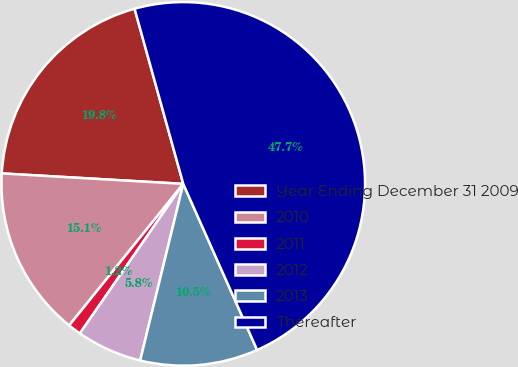<chart> <loc_0><loc_0><loc_500><loc_500><pie_chart><fcel>Year Ending December 31 2009<fcel>2010<fcel>2011<fcel>2012<fcel>2013<fcel>Thereafter<nl><fcel>19.77%<fcel>15.12%<fcel>1.17%<fcel>5.82%<fcel>10.47%<fcel>47.66%<nl></chart> 